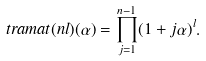<formula> <loc_0><loc_0><loc_500><loc_500>\ t r a m a t { ( n l ) } ( \alpha ) = \prod _ { j = 1 } ^ { n - 1 } ( 1 + j \alpha ) ^ { l } .</formula> 